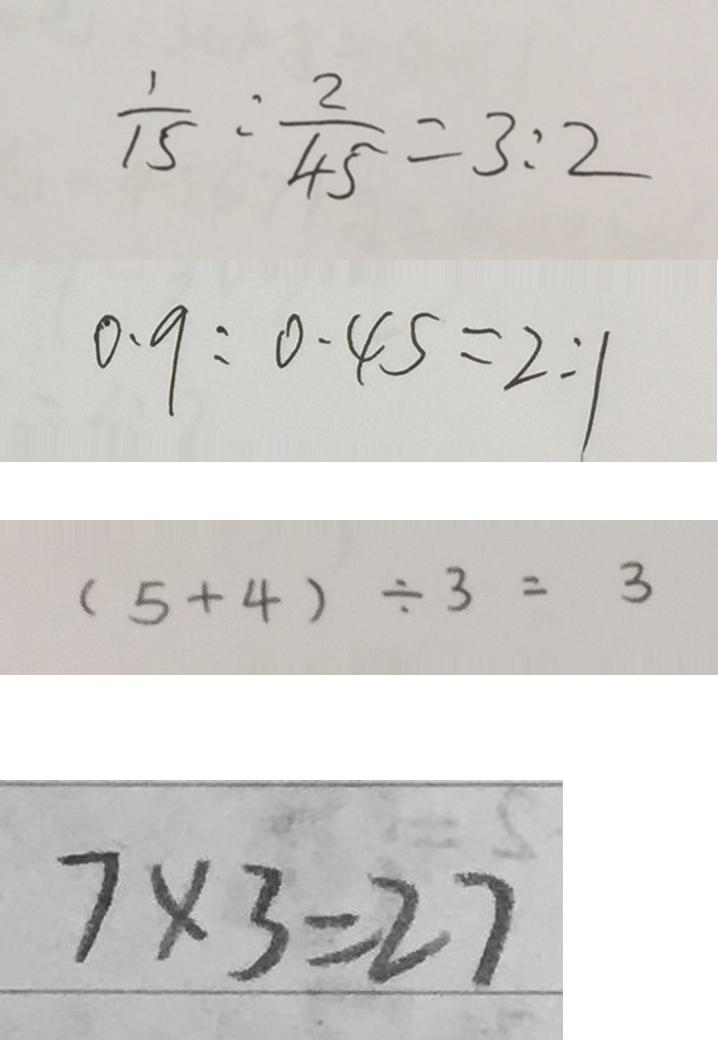<formula> <loc_0><loc_0><loc_500><loc_500>\frac { 1 } { 1 5 } : \frac { 2 } { 4 5 } = 3 : 2 
 0 . 9 : 0 . 4 5 = 2 : 1 
 ( 5 + 4 ) \div 3 = 3 
 7 \times 3 = 2 7</formula> 